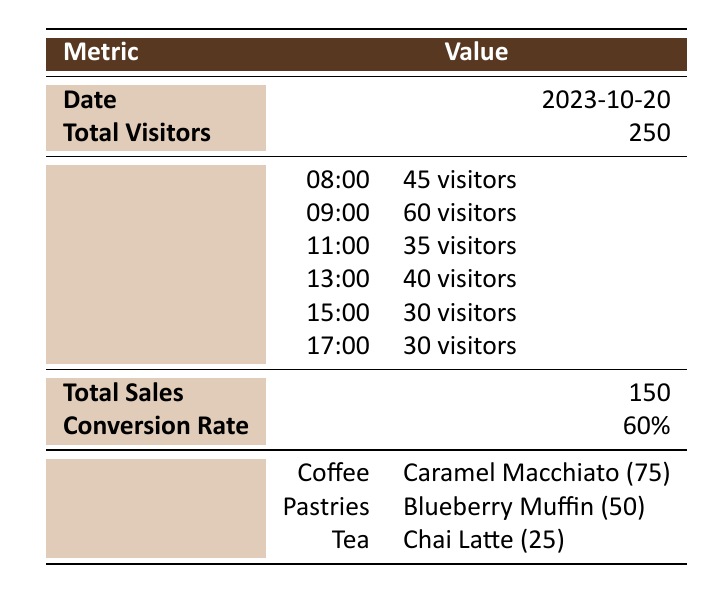What was the total number of visitors on October 20, 2023? The table shows the "Total Visitors" for the date "2023-10-20" as 250.
Answer: 250 Which hour had the highest number of visitors? According to the peak hours, 09:00 had the highest number of visitors at 60.
Answer: 09:00 What is the conversion rate expressed as a percentage? The table lists the "Conversion Rate" as 60%.
Answer: 60% How many visitors were there during the morning rush (08:00 - 09:00)? Adding the visitors from 08:00 (45) and 09:00 (60), the total during the morning rush is 105 visitors.
Answer: 105 Is the Caramel Macchiato the most popular item sold? Since the sales for Caramel Macchiato are 75, which is higher than any other item sales, yes, it is the most popular.
Answer: Yes What was the total number of visitors during the lunchtime flow (13:00)? The table shows that there were 40 visitors at 13:00 during lunchtime.
Answer: 40 If I wanted to order both a Blueberry Muffin and a Chai Latte, how many items would that be in total? Adding the sales of Blueberry Muffin (50) and Chai Latte (25), the total would be 75 items.
Answer: 75 What time had fewer visitors than 35? Looking at the peak hours, 11:00 had 35 visitors, but both 15:00 and 17:00 had only 30 visitors each, which is fewer.
Answer: 15:00 and 17:00 Was the daily foot traffic more or less than 300 visitors? Since the "Total Visitors" is 250, which is less than 300, the answer is that it was less.
Answer: Less 